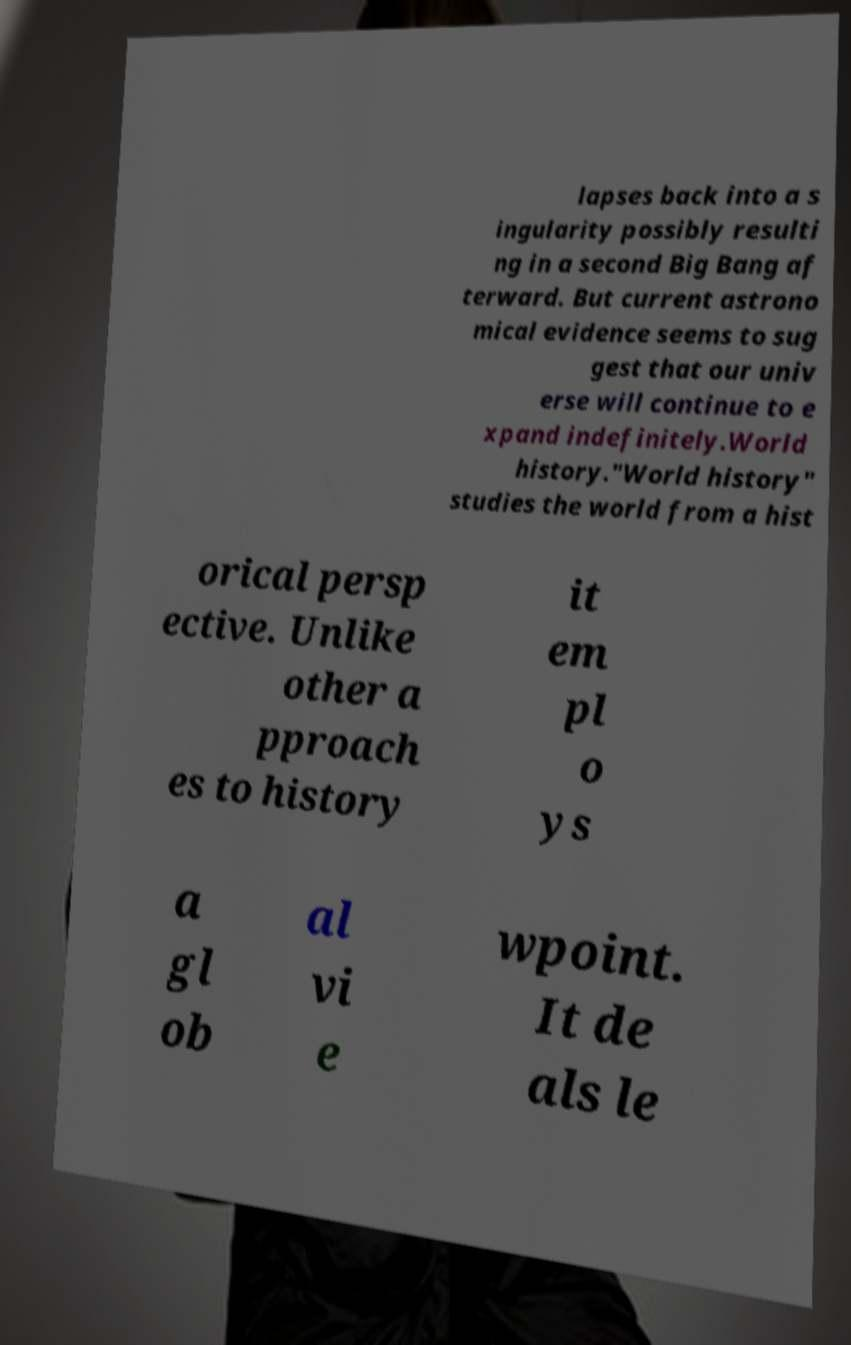Can you accurately transcribe the text from the provided image for me? lapses back into a s ingularity possibly resulti ng in a second Big Bang af terward. But current astrono mical evidence seems to sug gest that our univ erse will continue to e xpand indefinitely.World history."World history" studies the world from a hist orical persp ective. Unlike other a pproach es to history it em pl o ys a gl ob al vi e wpoint. It de als le 